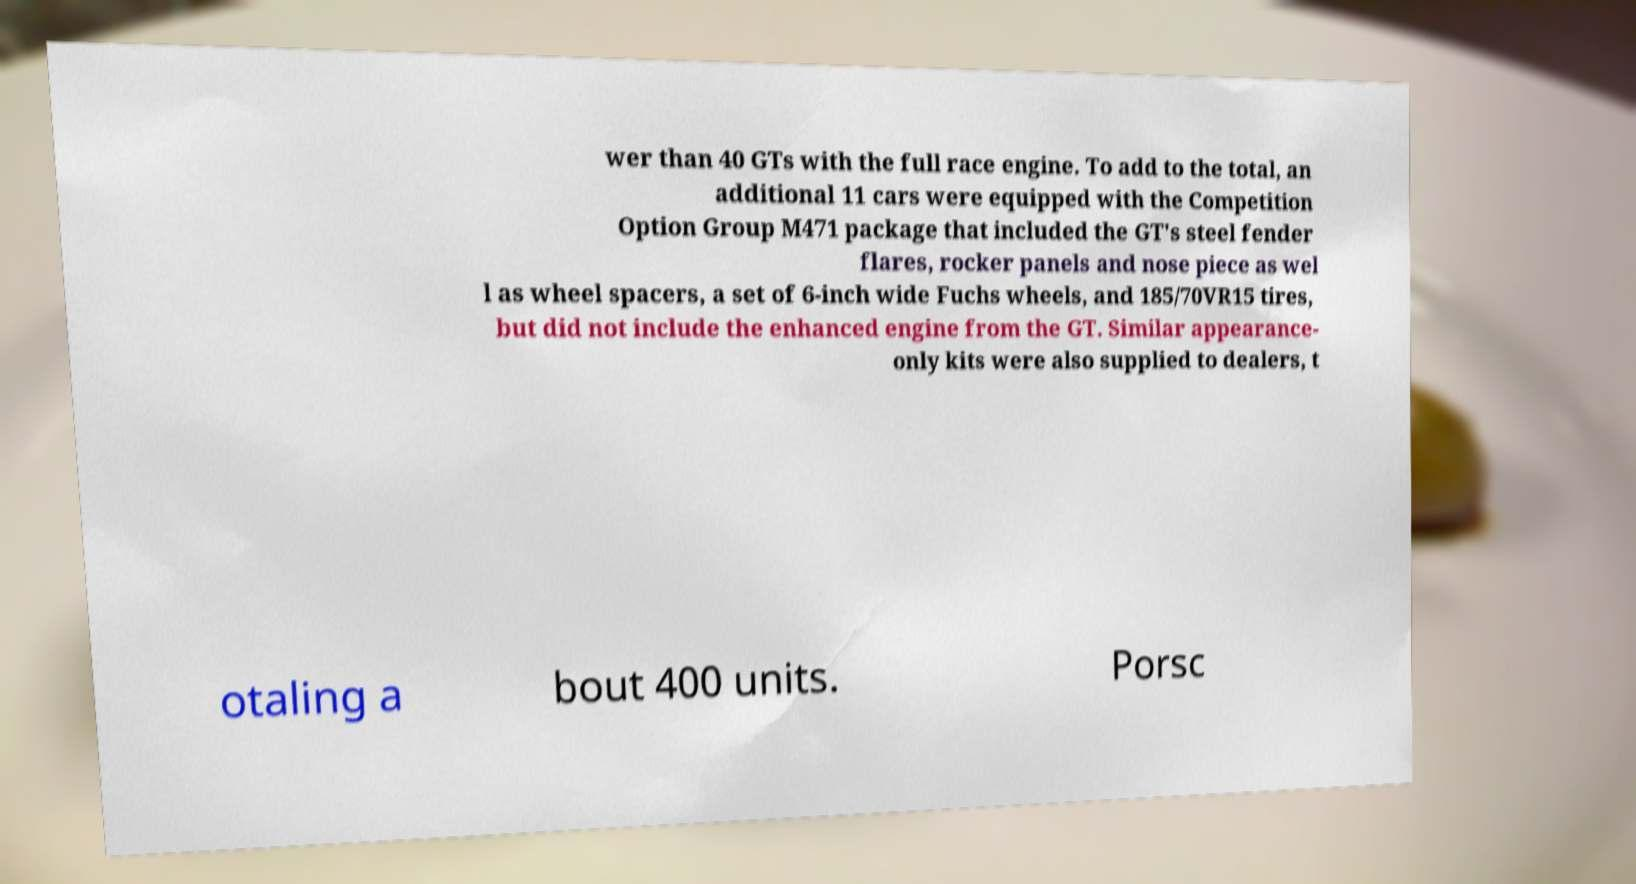Can you read and provide the text displayed in the image?This photo seems to have some interesting text. Can you extract and type it out for me? wer than 40 GTs with the full race engine. To add to the total, an additional 11 cars were equipped with the Competition Option Group M471 package that included the GT's steel fender flares, rocker panels and nose piece as wel l as wheel spacers, a set of 6-inch wide Fuchs wheels, and 185/70VR15 tires, but did not include the enhanced engine from the GT. Similar appearance- only kits were also supplied to dealers, t otaling a bout 400 units. Porsc 